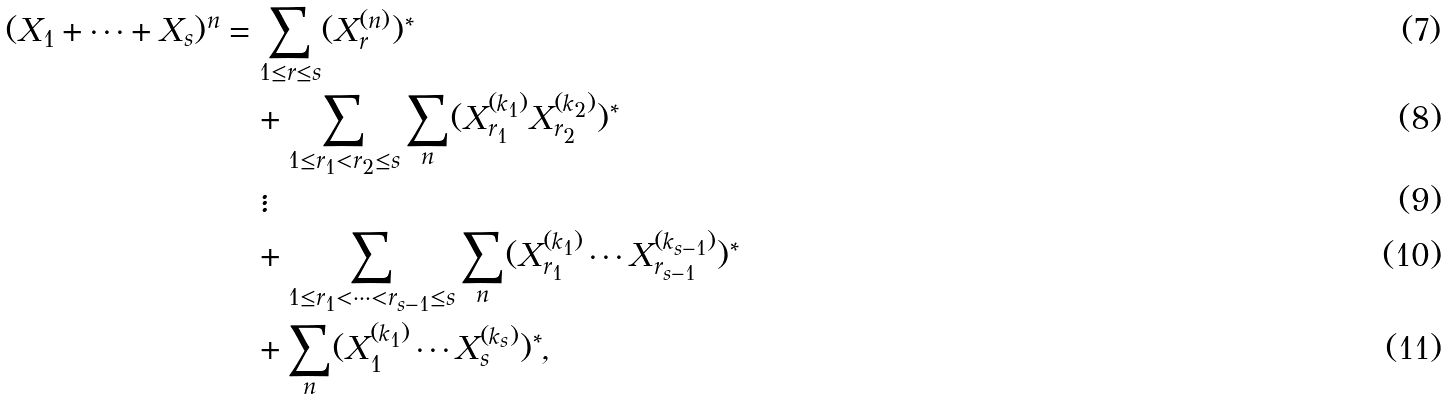<formula> <loc_0><loc_0><loc_500><loc_500>( X _ { 1 } + \cdots + X _ { s } ) ^ { n } & = \sum _ { \substack { 1 \leq r \leq s } } ( X _ { r } ^ { ( n ) } ) ^ { \ast } \\ & \quad + \sum _ { 1 \leq r _ { 1 } < r _ { 2 } \leq s } \sum _ { n } ( X _ { r _ { 1 } } ^ { ( k _ { 1 } ) } X _ { r _ { 2 } } ^ { ( k _ { 2 } ) } ) ^ { \ast } \\ & \quad \, \vdots \\ & \quad + \sum _ { 1 \leq r _ { 1 } < \cdots < r _ { s - 1 } \leq s } \sum _ { n } ( X _ { r _ { 1 } } ^ { ( k _ { 1 } ) } \cdots X _ { r _ { s - 1 } } ^ { ( k _ { s - 1 } ) } ) ^ { \ast } \\ & \quad + \sum _ { n } ( X _ { 1 } ^ { ( k _ { 1 } ) } \cdots X _ { s } ^ { ( k _ { s } ) } ) ^ { \ast } ,</formula> 